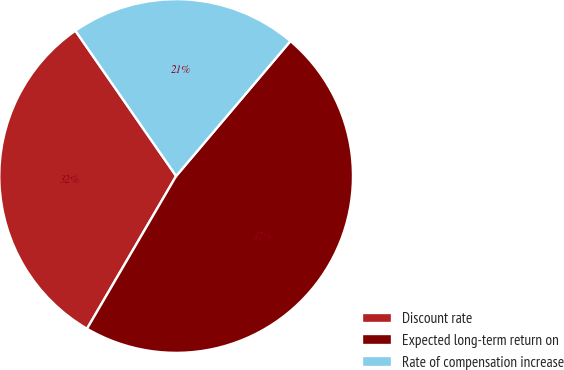Convert chart to OTSL. <chart><loc_0><loc_0><loc_500><loc_500><pie_chart><fcel>Discount rate<fcel>Expected long-term return on<fcel>Rate of compensation increase<nl><fcel>31.94%<fcel>47.22%<fcel>20.83%<nl></chart> 